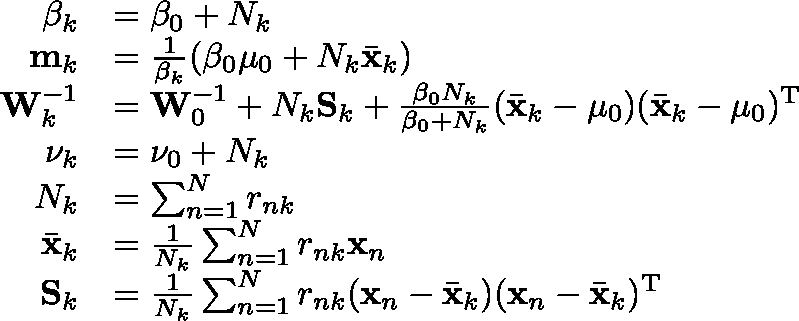<formula> <loc_0><loc_0><loc_500><loc_500>{ \begin{array} { r l } { \beta _ { k } } & { = \beta _ { 0 } + N _ { k } } \\ { m _ { k } } & { = { \frac { 1 } { \beta _ { k } } } ( \beta _ { 0 } \mu _ { 0 } + N _ { k } { \bar { x } } _ { k } ) } \\ { W _ { k } ^ { - 1 } } & { = W _ { 0 } ^ { - 1 } + N _ { k } S _ { k } + { \frac { \beta _ { 0 } N _ { k } } { \beta _ { 0 } + N _ { k } } } ( { \bar { x } } _ { k } - \mu _ { 0 } ) ( { \bar { x } } _ { k } - \mu _ { 0 } ) ^ { T } } \\ { \nu _ { k } } & { = \nu _ { 0 } + N _ { k } } \\ { N _ { k } } & { = \sum _ { n = 1 } ^ { N } r _ { n k } } \\ { { \bar { x } } _ { k } } & { = { \frac { 1 } { N _ { k } } } \sum _ { n = 1 } ^ { N } r _ { n k } x _ { n } } \\ { S _ { k } } & { = { \frac { 1 } { N _ { k } } } \sum _ { n = 1 } ^ { N } r _ { n k } ( x _ { n } - { \bar { x } } _ { k } ) ( x _ { n } - { \bar { x } } _ { k } ) ^ { T } } \end{array} }</formula> 